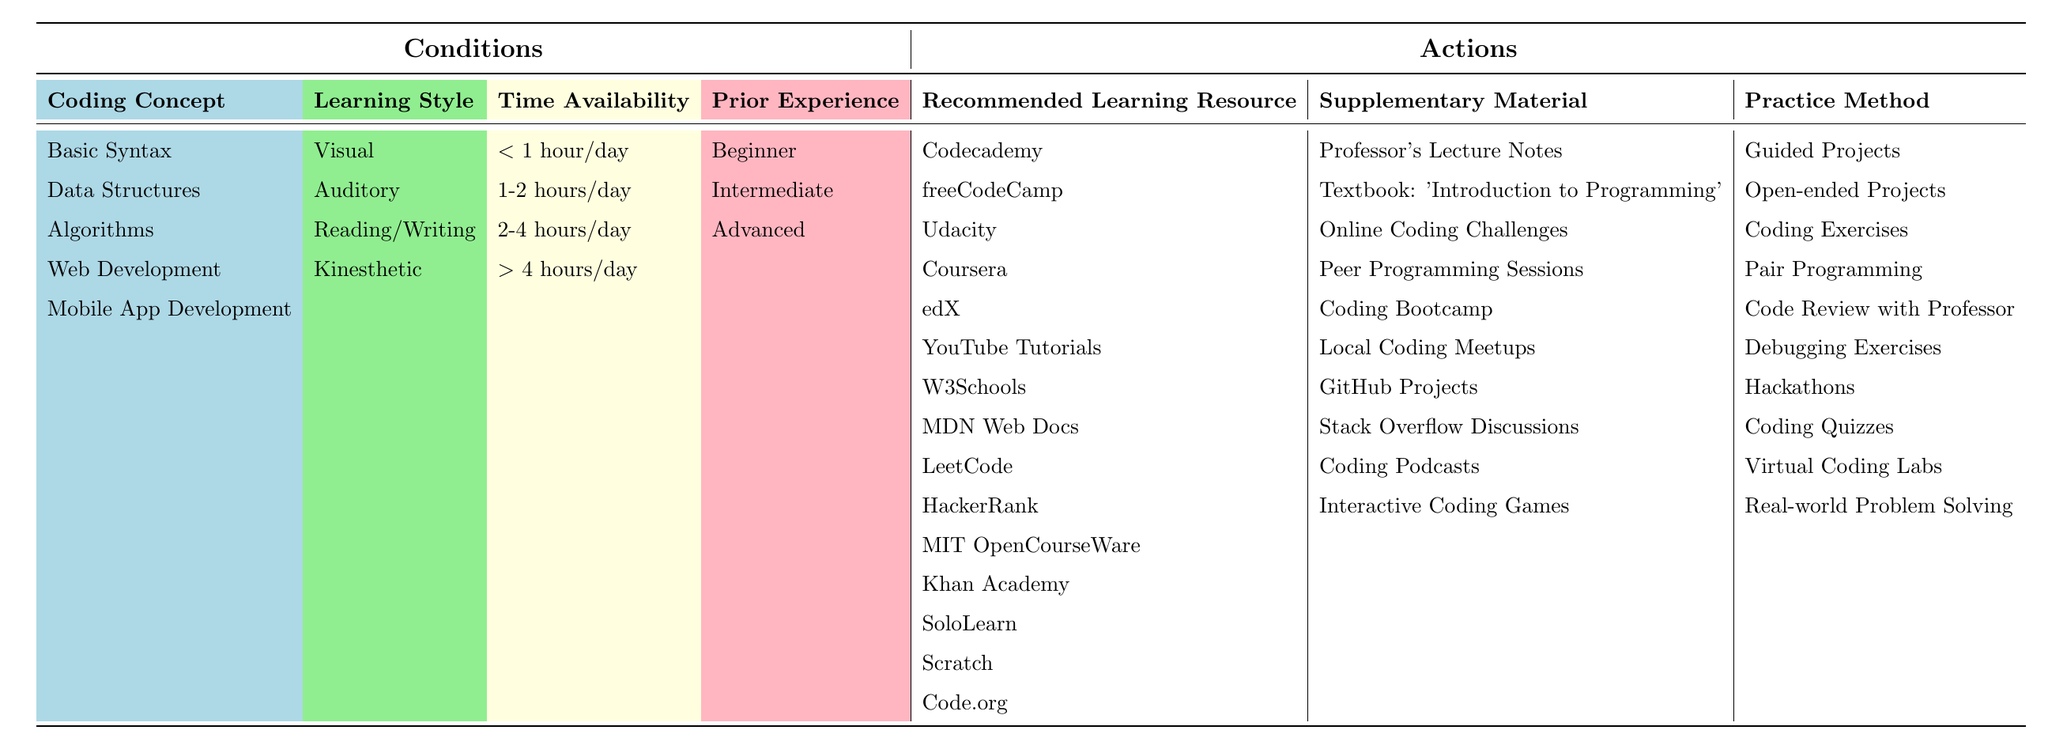What is the recommended learning resource for beginners focusing on Basic Syntax and having a visual learning style? From the table, we look at the row where the Coding Concept is Basic Syntax, the Learning Style is Visual, and the Prior Experience is Beginner. The resource listed under these conditions is Codecademy.
Answer: Codecademy Which supplementary material is suggested for intermediate learners focusing on Data Structures with an auditory learning style? For the Data Structures row, the Prior Experience is Intermediate, and the Learning Style is Auditory. The supplementary material listed for this combination is the Textbook: 'Introduction to Programming'.
Answer: Textbook: 'Introduction to Programming' True or False: All recommended resources for Mobile App Development are specified in the table. In the table, there is a row for Mobile App Development, but it is incomplete as the Learning Style, Time Availability, and Prior Experience are not specified. Since not all information is present, the statement is false.
Answer: False What is the practice method recommended for those learning Algorithms with a reading/writing style and advanced experience? Referring to the row for Algorithms where the Learning Style is Reading/Writing and Prior Experience is Advanced, the Practice Method provided is Coding Exercises.
Answer: Coding Exercises If a beginner has less than 1 hour per day to study Basic Syntax, what supplementary material is recommended? Under the Basic Syntax row for a Beginner with less than 1 hour/day availability, the supplementary material listed is Professor's Lecture Notes.
Answer: Professor's Lecture Notes How many different practice methods are suggested for learners focusing on Mobile App Development? Looking at the rows related to Mobile App Development, there are multiple recommended resources, including YouTube Tutorials, W3Schools, MDN Web Docs, LeetCode, HackerRank, MIT OpenCourseWare, Khan Academy, SoloLearn, Scratch, and Code.org. However, not all of them indicate specific practice methods, which limits the distinct practice methods related to this coding concept. The distinct valid practice methods tied to Mobile App Development are therefore Coding Bootcamp and Code Review with Professor, which totals to two different methods.
Answer: 2 What is the average time availability needed for learners focusing on Web Development? In the Web Development row, the time availability is specified as more than 4 hours/day. As this is a single value and does not involve multiple data points, the average remains the same as the time frame specified: more than 4 hours/day.
Answer: More than 4 hours/day Which recommended learning resource is common across different coding concepts in the table? Analyzing the rows across all coding concepts, we find that multiple resources are mentioned, but some like Coursera appear only under Web Development. Others, specific resources intended for foundational coding, such as Codecademy and freeCodeCamp, also appear specifically under Basic Syntax and Data Structures respectively, implying commonality in basic coding foundations as recommended resources among differing coding focus areas. This leads us to conclude that there are indeed common recommendations for resources suitable for foundational learning across the coding concepts listed.
Answer: Codecademy and freeCodeCamp are common foundations 